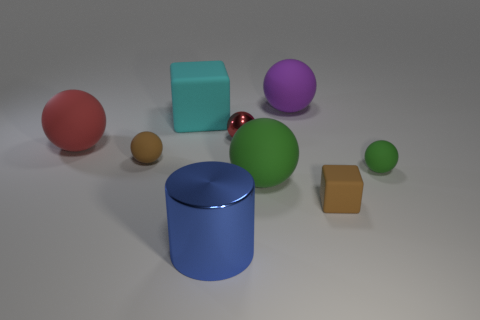Subtract all green spheres. How many spheres are left? 4 Subtract all brown spheres. How many spheres are left? 5 Subtract all cyan spheres. Subtract all brown cubes. How many spheres are left? 6 Add 1 blue metal cylinders. How many objects exist? 10 Subtract all blocks. How many objects are left? 7 Subtract 0 purple blocks. How many objects are left? 9 Subtract all tiny green rubber things. Subtract all brown matte things. How many objects are left? 6 Add 2 large purple rubber objects. How many large purple rubber objects are left? 3 Add 5 small brown shiny things. How many small brown shiny things exist? 5 